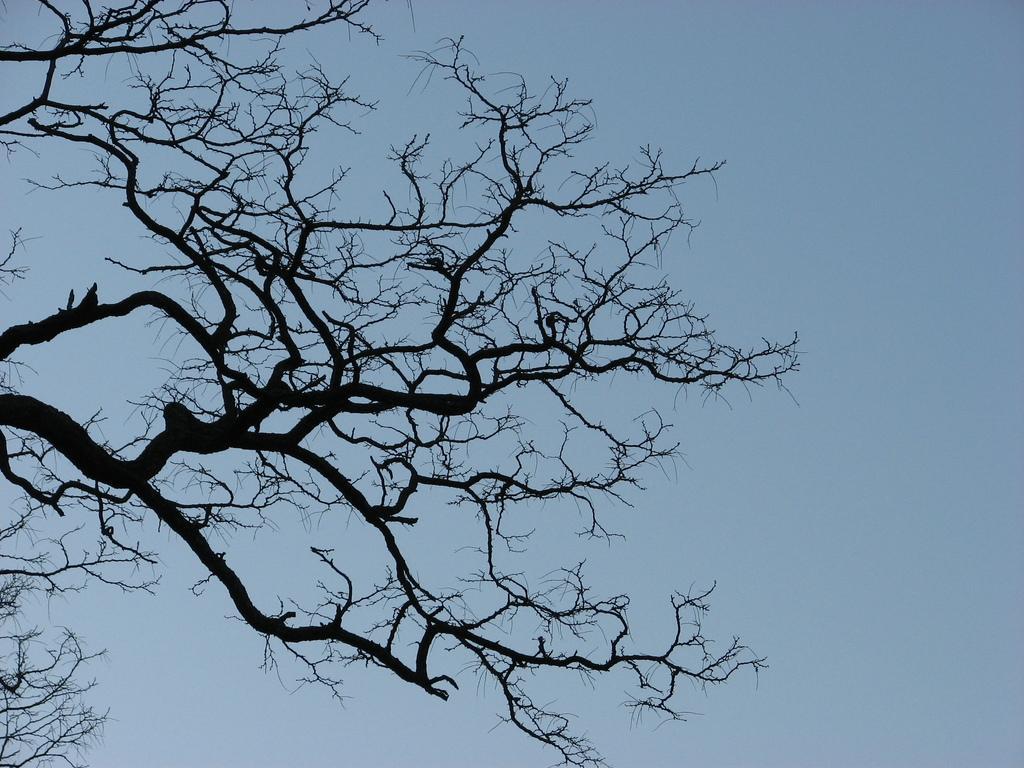Describe this image in one or two sentences. In this image we can see a dry tree and sky. 